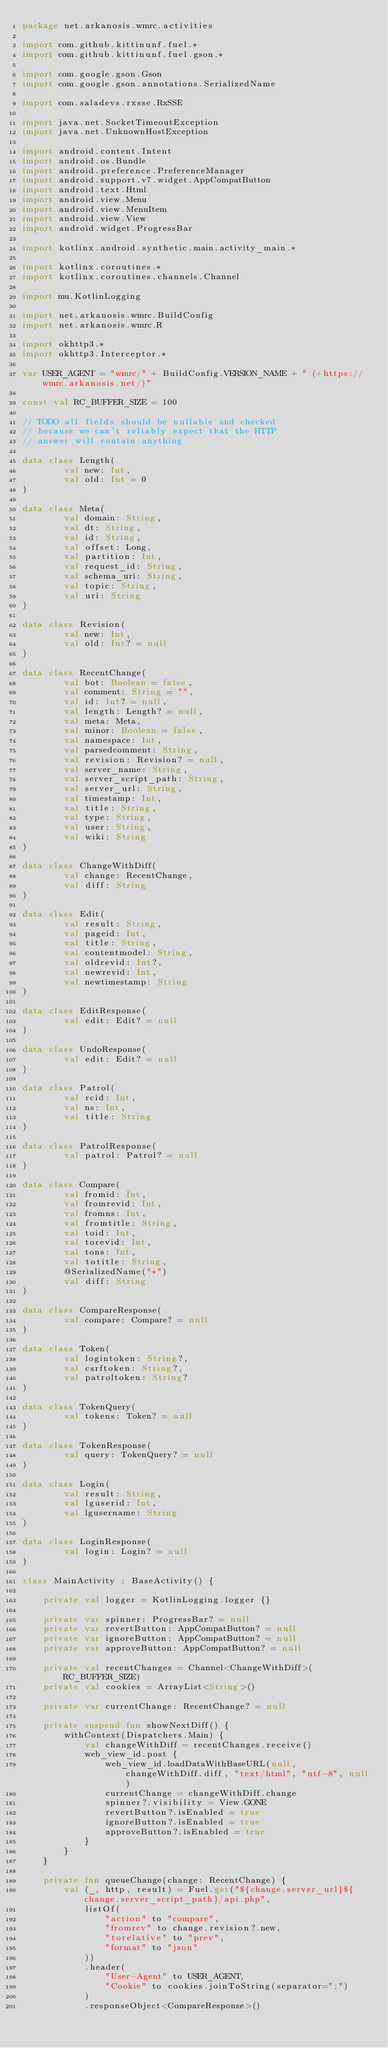Convert code to text. <code><loc_0><loc_0><loc_500><loc_500><_Kotlin_>package net.arkanosis.wmrc.activities

import com.github.kittinunf.fuel.*
import com.github.kittinunf.fuel.gson.*

import com.google.gson.Gson
import com.google.gson.annotations.SerializedName

import com.saladevs.rxsse.RxSSE

import java.net.SocketTimeoutException
import java.net.UnknownHostException

import android.content.Intent
import android.os.Bundle
import android.preference.PreferenceManager
import android.support.v7.widget.AppCompatButton
import android.text.Html
import android.view.Menu
import android.view.MenuItem
import android.view.View
import android.widget.ProgressBar

import kotlinx.android.synthetic.main.activity_main.*

import kotlinx.coroutines.*
import kotlinx.coroutines.channels.Channel

import mu.KotlinLogging

import net.arkanosis.wmrc.BuildConfig
import net.arkanosis.wmrc.R

import okhttp3.*
import okhttp3.Interceptor.*

var USER_AGENT = "wmrc/" + BuildConfig.VERSION_NAME + " (+https://wmrc.arkanosis.net/)"

const val RC_BUFFER_SIZE = 100

// TODO all fields should be nullable and checked
// because we can't reliably expect that the HTTP
// answer will contain anything

data class Length(
        val new: Int,
        val old: Int = 0
)

data class Meta(
        val domain: String,
        val dt: String,
        val id: String,
        val offset: Long,
        val partition: Int,
        val request_id: String,
        val schema_uri: String,
        val topic: String,
        val uri: String
)

data class Revision(
        val new: Int,
        val old: Int? = null
)

data class RecentChange(
        val bot: Boolean = false,
        val comment: String = "",
        val id: Int? = null,
        val length: Length? = null,
        val meta: Meta,
        val minor: Boolean = false,
        val namespace: Int,
        val parsedcomment: String,
        val revision: Revision? = null,
        val server_name: String,
        val server_script_path: String,
        val server_url: String,
        val timestamp: Int,
        val title: String,
        val type: String,
        val user: String,
        val wiki: String
)

data class ChangeWithDiff(
        val change: RecentChange,
        val diff: String
)

data class Edit(
        val result: String,
        val pageid: Int,
        val title: String,
        val contentmodel: String,
        val oldrevid: Int?,
        val newrevid: Int,
        val newtimestamp: String
)

data class EditResponse(
        val edit: Edit? = null
)

data class UndoResponse(
        val edit: Edit? = null
)

data class Patrol(
        val rcid: Int,
        val ns: Int,
        val title: String
)

data class PatrolResponse(
        val patrol: Patrol? = null
)

data class Compare(
        val fromid: Int,
        val fromrevid: Int,
        val fromns: Int,
        val fromtitle: String,
        val toid: Int,
        val torevid: Int,
        val tons: Int,
        val totitle: String,
        @SerializedName("*")
        val diff: String
)

data class CompareResponse(
        val compare: Compare? = null
)

data class Token(
        val logintoken: String?,
        val csrftoken: String?,
        val patroltoken: String?
)

data class TokenQuery(
        val tokens: Token? = null
)

data class TokenResponse(
        val query: TokenQuery? = null
)

data class Login(
        val result: String,
        val lguserid: Int,
        val lgusername: String
)

data class LoginResponse(
        val login: Login? = null
)

class MainActivity : BaseActivity() {

    private val logger = KotlinLogging.logger {}

    private var spinner: ProgressBar? = null
    private var revertButton: AppCompatButton? = null
    private var ignoreButton: AppCompatButton? = null
    private var approveButton: AppCompatButton? = null

    private val recentChanges = Channel<ChangeWithDiff>(RC_BUFFER_SIZE)
    private val cookies = ArrayList<String>()

    private var currentChange: RecentChange? = null

    private suspend fun showNextDiff() {
        withContext(Dispatchers.Main) {
            val changeWithDiff = recentChanges.receive()
            web_view_id.post {
                web_view_id.loadDataWithBaseURL(null, changeWithDiff.diff, "text/html", "utf-8", null)
                currentChange = changeWithDiff.change
                spinner?.visibility = View.GONE
                revertButton?.isEnabled = true
                ignoreButton?.isEnabled = true
                approveButton?.isEnabled = true
            }
        }
    }

    private fun queueChange(change: RecentChange) {
        val (_, http, result) = Fuel.get("${change.server_url}${change.server_script_path}/api.php",
            listOf(
                "action" to "compare",
                "fromrev" to change.revision?.new,
                "torelative" to "prev",
                "format" to "json"
            ))
            .header(
                "User-Agent" to USER_AGENT,
                "Cookie" to cookies.joinToString(separator=";")
            )
            .responseObject<CompareResponse>()</code> 